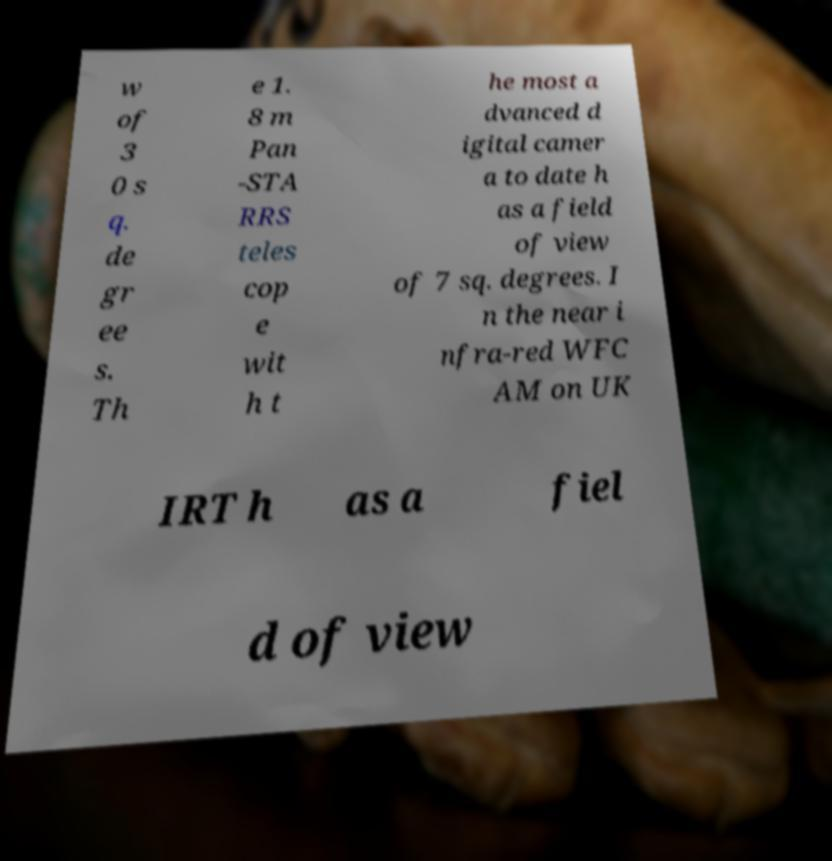Please read and relay the text visible in this image. What does it say? w of 3 0 s q. de gr ee s. Th e 1. 8 m Pan -STA RRS teles cop e wit h t he most a dvanced d igital camer a to date h as a field of view of 7 sq. degrees. I n the near i nfra-red WFC AM on UK IRT h as a fiel d of view 